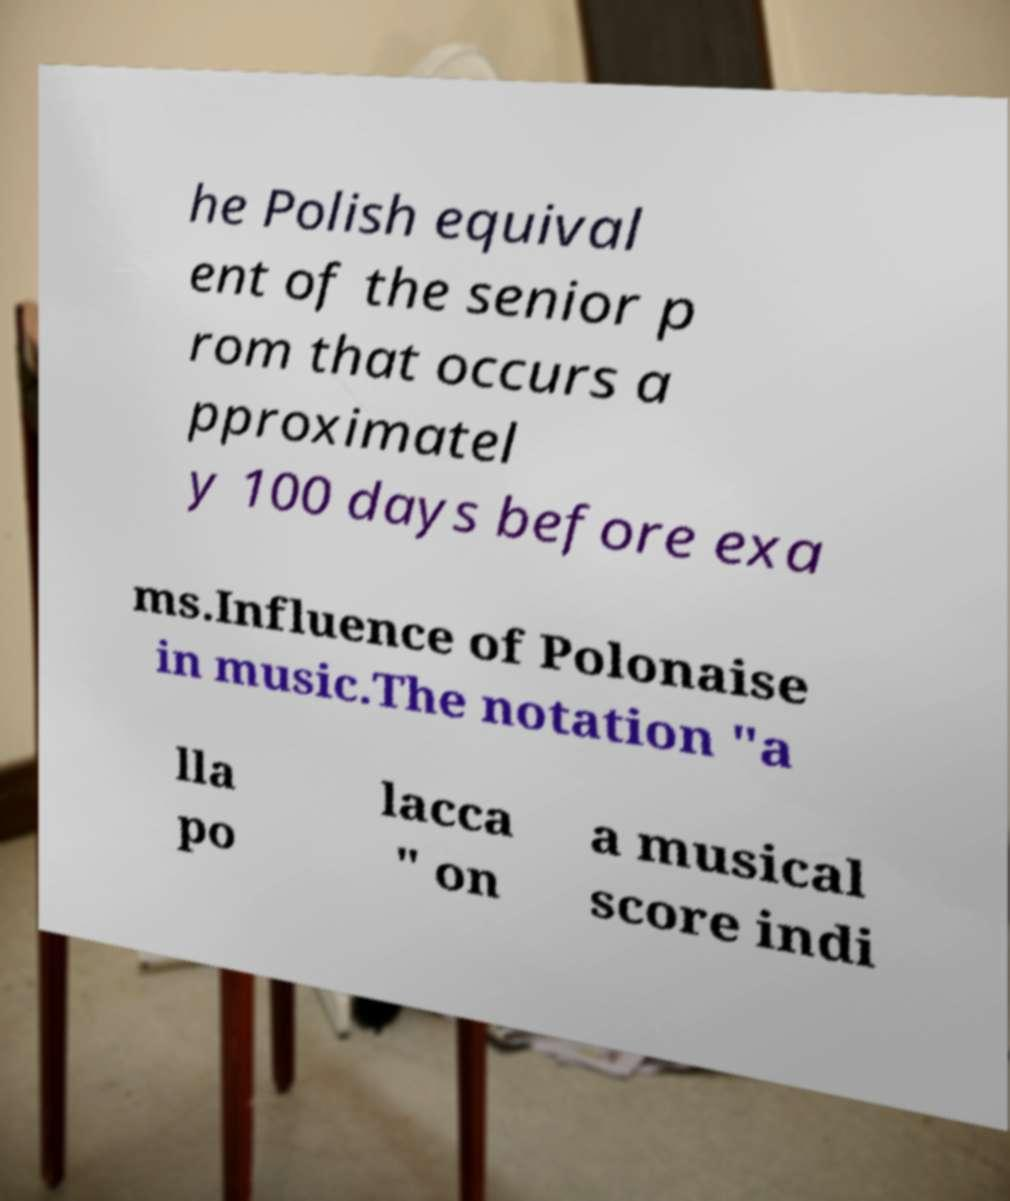For documentation purposes, I need the text within this image transcribed. Could you provide that? he Polish equival ent of the senior p rom that occurs a pproximatel y 100 days before exa ms.Influence of Polonaise in music.The notation "a lla po lacca " on a musical score indi 